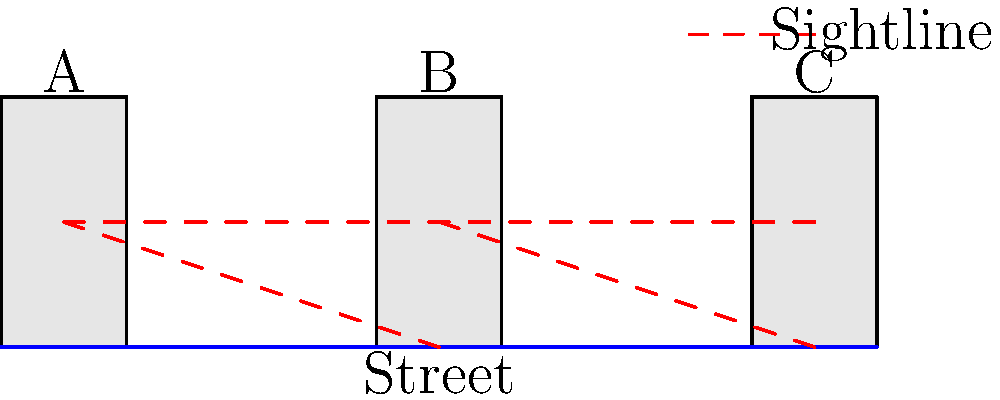In the urban layout shown, which building placement provides the best natural surveillance of the street according to CPTED principles? To answer this question, we need to consider the principles of Crime Prevention Through Environmental Design (CPTED), specifically the concept of natural surveillance. Let's analyze the diagram step-by-step:

1. The diagram shows three buildings (A, B, and C) along a street.
2. Natural surveillance in CPTED refers to the ability to see what's happening in the surrounding area, which can deter criminal activity.
3. The red dashed lines represent sightlines from the buildings to the street.
4. Building A has a clear view of the area directly in front of it and partially down the street to the right.
5. Building B has the most extensive sightlines, covering areas in front of buildings A and C, as well as its immediate surroundings.
6. Building C has a view of its immediate front area and partially down the street to the left.
7. The staggered arrangement of buildings B and C creates overlapping sightlines, increasing overall surveillance.
8. Building B's central position allows it to have the most comprehensive view of the street and the areas in front of the other buildings.

Based on this analysis, Building B provides the best natural surveillance of the street. Its central location and the staggered arrangement with other buildings allow for maximum visibility of the surrounding area, which is a key principle in CPTED for crime prevention.
Answer: Building B 